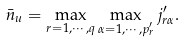Convert formula to latex. <formula><loc_0><loc_0><loc_500><loc_500>\bar { n } _ { u } = \max _ { r = 1 , \cdots , q } \max _ { \alpha = 1 , \cdots , p ^ { \prime } _ { r } } j ^ { \prime } _ { r \alpha } .</formula> 